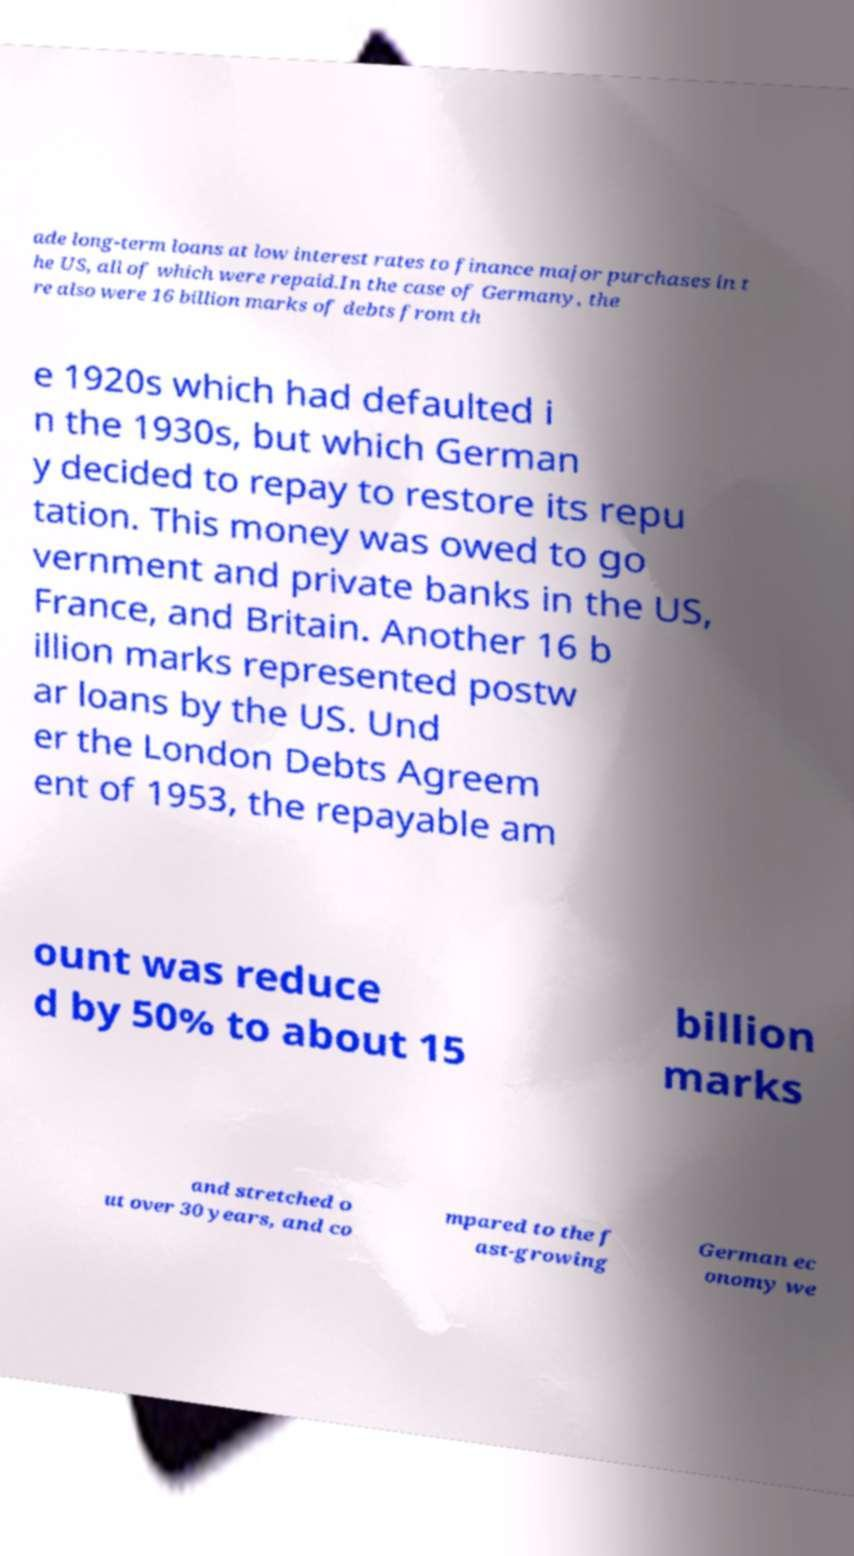What messages or text are displayed in this image? I need them in a readable, typed format. ade long-term loans at low interest rates to finance major purchases in t he US, all of which were repaid.In the case of Germany, the re also were 16 billion marks of debts from th e 1920s which had defaulted i n the 1930s, but which German y decided to repay to restore its repu tation. This money was owed to go vernment and private banks in the US, France, and Britain. Another 16 b illion marks represented postw ar loans by the US. Und er the London Debts Agreem ent of 1953, the repayable am ount was reduce d by 50% to about 15 billion marks and stretched o ut over 30 years, and co mpared to the f ast-growing German ec onomy we 